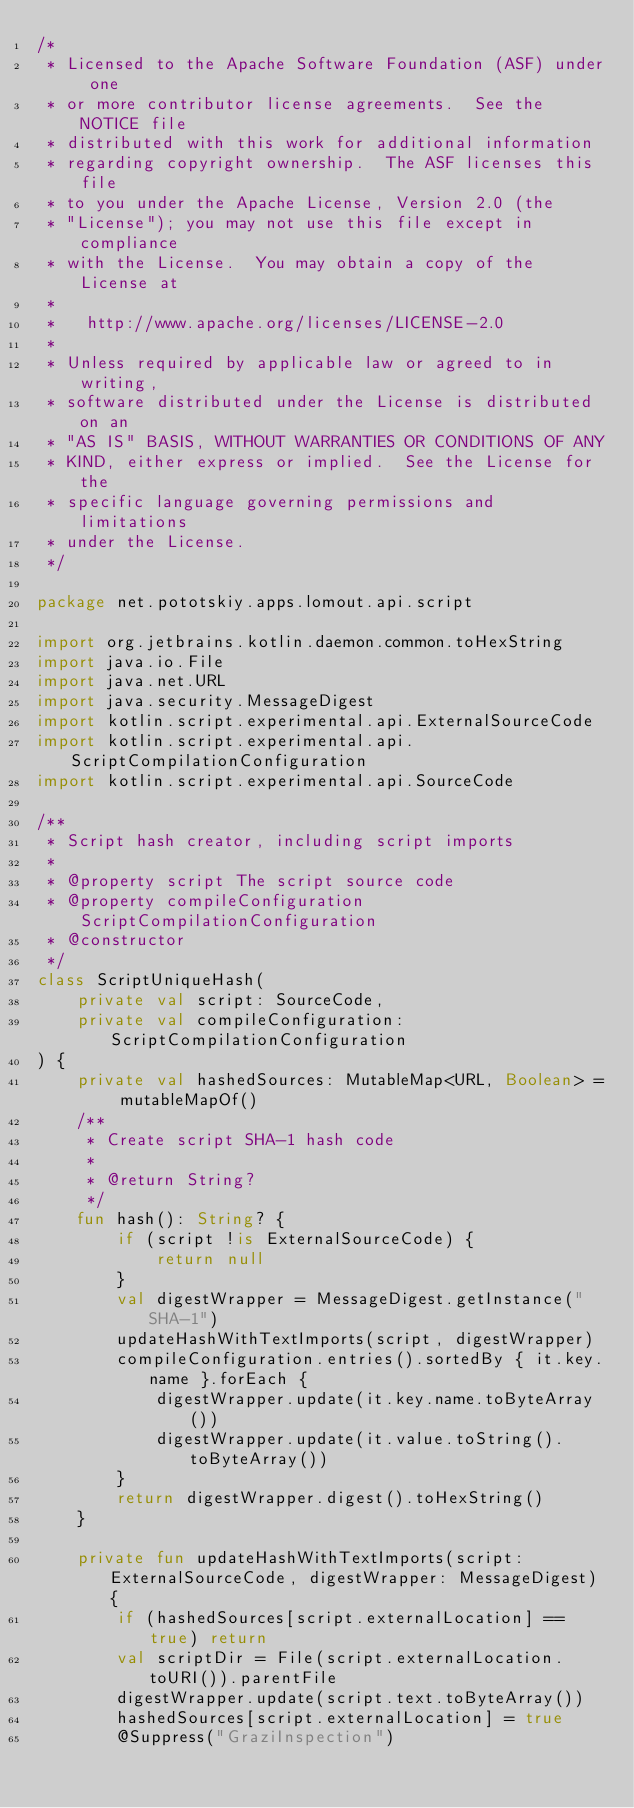Convert code to text. <code><loc_0><loc_0><loc_500><loc_500><_Kotlin_>/*
 * Licensed to the Apache Software Foundation (ASF) under one
 * or more contributor license agreements.  See the NOTICE file
 * distributed with this work for additional information
 * regarding copyright ownership.  The ASF licenses this file
 * to you under the Apache License, Version 2.0 (the
 * "License"); you may not use this file except in compliance
 * with the License.  You may obtain a copy of the License at
 *
 *   http://www.apache.org/licenses/LICENSE-2.0
 *
 * Unless required by applicable law or agreed to in writing,
 * software distributed under the License is distributed on an
 * "AS IS" BASIS, WITHOUT WARRANTIES OR CONDITIONS OF ANY
 * KIND, either express or implied.  See the License for the
 * specific language governing permissions and limitations
 * under the License.
 */

package net.pototskiy.apps.lomout.api.script

import org.jetbrains.kotlin.daemon.common.toHexString
import java.io.File
import java.net.URL
import java.security.MessageDigest
import kotlin.script.experimental.api.ExternalSourceCode
import kotlin.script.experimental.api.ScriptCompilationConfiguration
import kotlin.script.experimental.api.SourceCode

/**
 * Script hash creator, including script imports
 *
 * @property script The script source code
 * @property compileConfiguration ScriptCompilationConfiguration
 * @constructor
 */
class ScriptUniqueHash(
    private val script: SourceCode,
    private val compileConfiguration: ScriptCompilationConfiguration
) {
    private val hashedSources: MutableMap<URL, Boolean> = mutableMapOf()
    /**
     * Create script SHA-1 hash code
     *
     * @return String?
     */
    fun hash(): String? {
        if (script !is ExternalSourceCode) {
            return null
        }
        val digestWrapper = MessageDigest.getInstance("SHA-1")
        updateHashWithTextImports(script, digestWrapper)
        compileConfiguration.entries().sortedBy { it.key.name }.forEach {
            digestWrapper.update(it.key.name.toByteArray())
            digestWrapper.update(it.value.toString().toByteArray())
        }
        return digestWrapper.digest().toHexString()
    }

    private fun updateHashWithTextImports(script: ExternalSourceCode, digestWrapper: MessageDigest) {
        if (hashedSources[script.externalLocation] == true) return
        val scriptDir = File(script.externalLocation.toURI()).parentFile
        digestWrapper.update(script.text.toByteArray())
        hashedSources[script.externalLocation] = true
        @Suppress("GraziInspection")</code> 